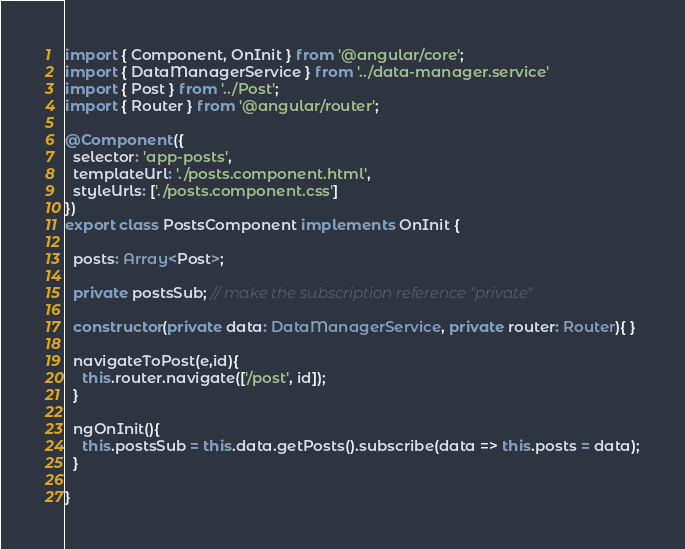Convert code to text. <code><loc_0><loc_0><loc_500><loc_500><_TypeScript_>import { Component, OnInit } from '@angular/core';
import { DataManagerService } from '../data-manager.service'
import { Post } from '../Post';
import { Router } from '@angular/router';

@Component({
  selector: 'app-posts',
  templateUrl: './posts.component.html',
  styleUrls: ['./posts.component.css']
})
export class PostsComponent implements OnInit {

  posts: Array<Post>;

  private postsSub; // make the subscription reference "private"

  constructor(private data: DataManagerService, private router: Router){ }

  navigateToPost(e,id){
    this.router.navigate(['/post', id]);
  }

  ngOnInit(){
    this.postsSub = this.data.getPosts().subscribe(data => this.posts = data);
  }

}
</code> 